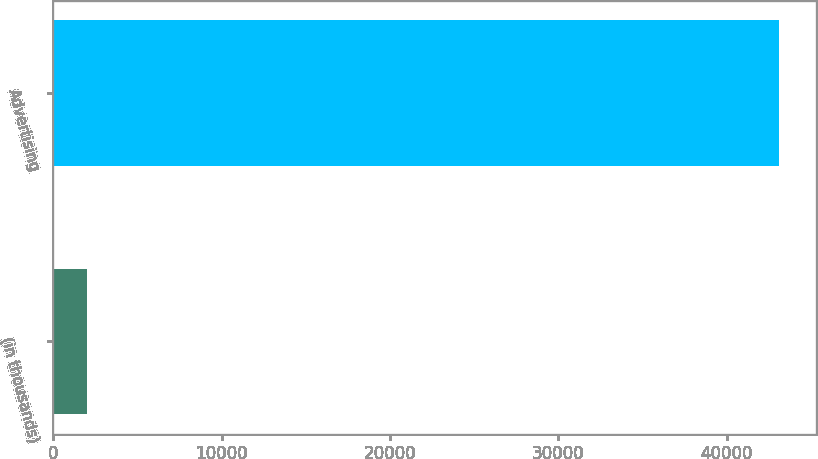Convert chart to OTSL. <chart><loc_0><loc_0><loc_500><loc_500><bar_chart><fcel>(in thousands)<fcel>Advertising<nl><fcel>2010<fcel>43119<nl></chart> 